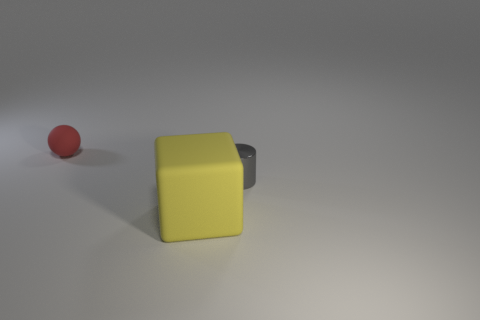Are there any other things that are the same color as the tiny metal cylinder?
Provide a short and direct response. No. There is a rubber thing that is behind the large yellow rubber cube; what is its size?
Provide a succinct answer. Small. Are there more tiny red metal cylinders than small gray metal things?
Keep it short and to the point. No. What is the large yellow block made of?
Keep it short and to the point. Rubber. What number of other objects are the same material as the cube?
Your answer should be compact. 1. How many small purple metallic cylinders are there?
Give a very brief answer. 0. Does the tiny object to the left of the large block have the same material as the big thing?
Your answer should be compact. Yes. Are there more small red things in front of the gray thing than red rubber spheres that are behind the small sphere?
Your answer should be very brief. No. What is the size of the yellow matte cube?
Offer a terse response. Large. The thing that is the same material as the ball is what shape?
Your answer should be very brief. Cube. 